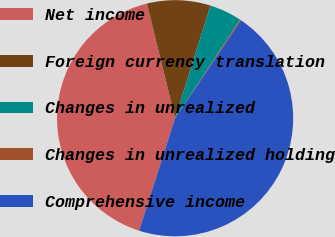Convert chart. <chart><loc_0><loc_0><loc_500><loc_500><pie_chart><fcel>Net income<fcel>Foreign currency translation<fcel>Changes in unrealized<fcel>Changes in unrealized holding<fcel>Comprehensive income<nl><fcel>41.24%<fcel>8.68%<fcel>4.42%<fcel>0.16%<fcel>45.5%<nl></chart> 